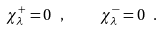Convert formula to latex. <formula><loc_0><loc_0><loc_500><loc_500>\chi ^ { + } _ { \lambda } = 0 \ , \quad \chi ^ { - } _ { \lambda } = 0 \ .</formula> 